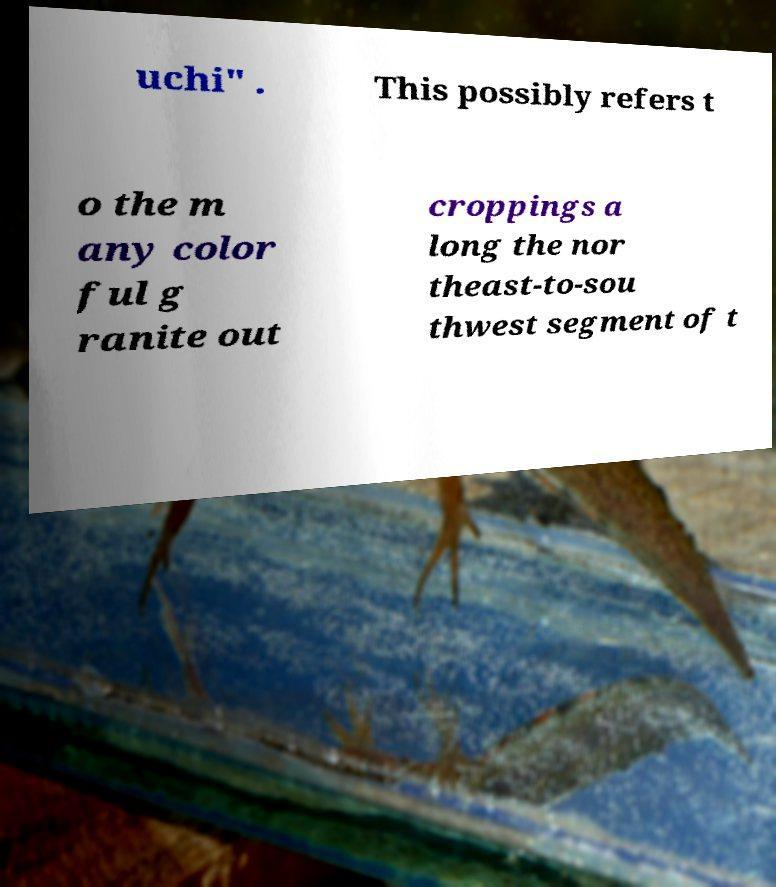For documentation purposes, I need the text within this image transcribed. Could you provide that? uchi" . This possibly refers t o the m any color ful g ranite out croppings a long the nor theast-to-sou thwest segment of t 